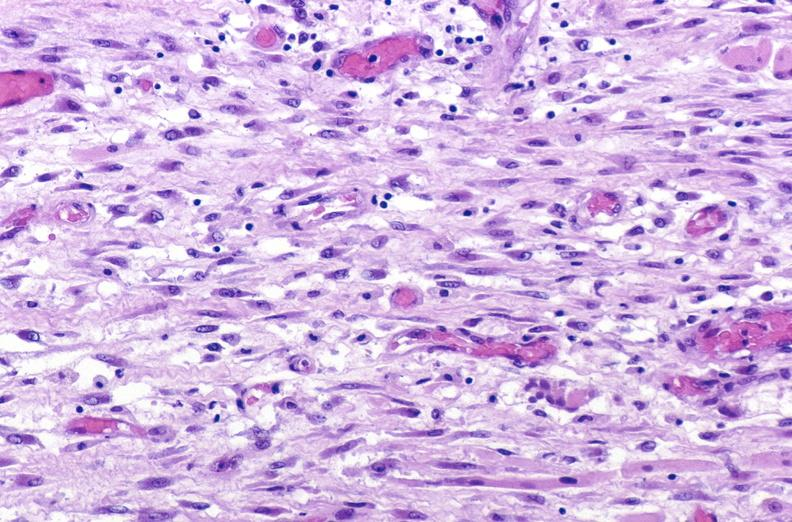what is present?
Answer the question using a single word or phrase. Muscle 